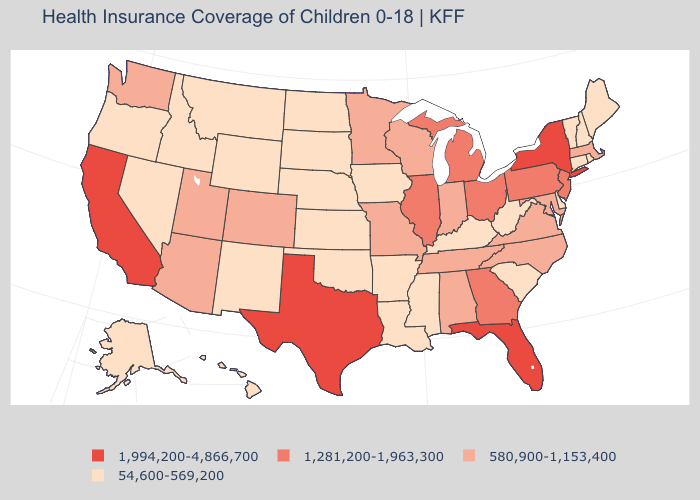Which states have the lowest value in the USA?
Concise answer only. Alaska, Arkansas, Connecticut, Delaware, Hawaii, Idaho, Iowa, Kansas, Kentucky, Louisiana, Maine, Mississippi, Montana, Nebraska, Nevada, New Hampshire, New Mexico, North Dakota, Oklahoma, Oregon, Rhode Island, South Carolina, South Dakota, Vermont, West Virginia, Wyoming. Does the first symbol in the legend represent the smallest category?
Answer briefly. No. Does the map have missing data?
Be succinct. No. Which states have the lowest value in the USA?
Short answer required. Alaska, Arkansas, Connecticut, Delaware, Hawaii, Idaho, Iowa, Kansas, Kentucky, Louisiana, Maine, Mississippi, Montana, Nebraska, Nevada, New Hampshire, New Mexico, North Dakota, Oklahoma, Oregon, Rhode Island, South Carolina, South Dakota, Vermont, West Virginia, Wyoming. Name the states that have a value in the range 54,600-569,200?
Quick response, please. Alaska, Arkansas, Connecticut, Delaware, Hawaii, Idaho, Iowa, Kansas, Kentucky, Louisiana, Maine, Mississippi, Montana, Nebraska, Nevada, New Hampshire, New Mexico, North Dakota, Oklahoma, Oregon, Rhode Island, South Carolina, South Dakota, Vermont, West Virginia, Wyoming. Name the states that have a value in the range 1,281,200-1,963,300?
Quick response, please. Georgia, Illinois, Michigan, New Jersey, Ohio, Pennsylvania. What is the lowest value in the USA?
Quick response, please. 54,600-569,200. What is the value of New York?
Answer briefly. 1,994,200-4,866,700. Does the first symbol in the legend represent the smallest category?
Keep it brief. No. Name the states that have a value in the range 54,600-569,200?
Concise answer only. Alaska, Arkansas, Connecticut, Delaware, Hawaii, Idaho, Iowa, Kansas, Kentucky, Louisiana, Maine, Mississippi, Montana, Nebraska, Nevada, New Hampshire, New Mexico, North Dakota, Oklahoma, Oregon, Rhode Island, South Carolina, South Dakota, Vermont, West Virginia, Wyoming. What is the highest value in the Northeast ?
Be succinct. 1,994,200-4,866,700. Does the first symbol in the legend represent the smallest category?
Answer briefly. No. Does the map have missing data?
Write a very short answer. No. Which states hav the highest value in the Northeast?
Quick response, please. New York. Name the states that have a value in the range 1,281,200-1,963,300?
Answer briefly. Georgia, Illinois, Michigan, New Jersey, Ohio, Pennsylvania. 